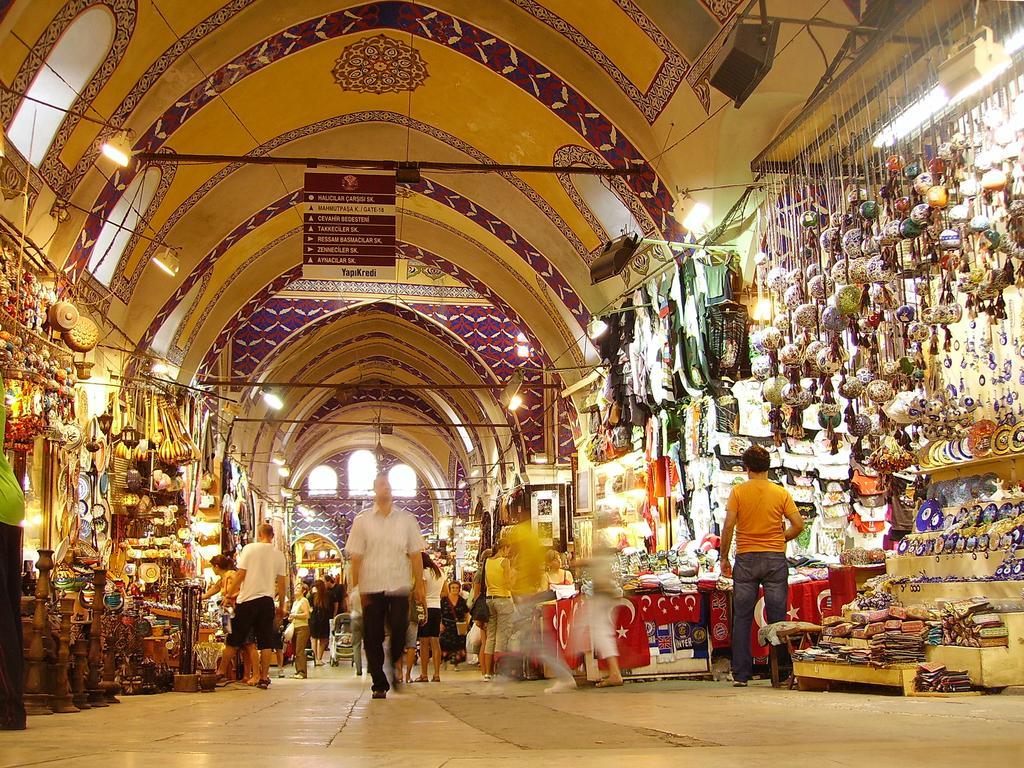How would you summarize this image in a sentence or two? In the image few people are standing and walking. Behind them there are some stores. At the top of the image there is roof and there are some poles and banners and lights. 